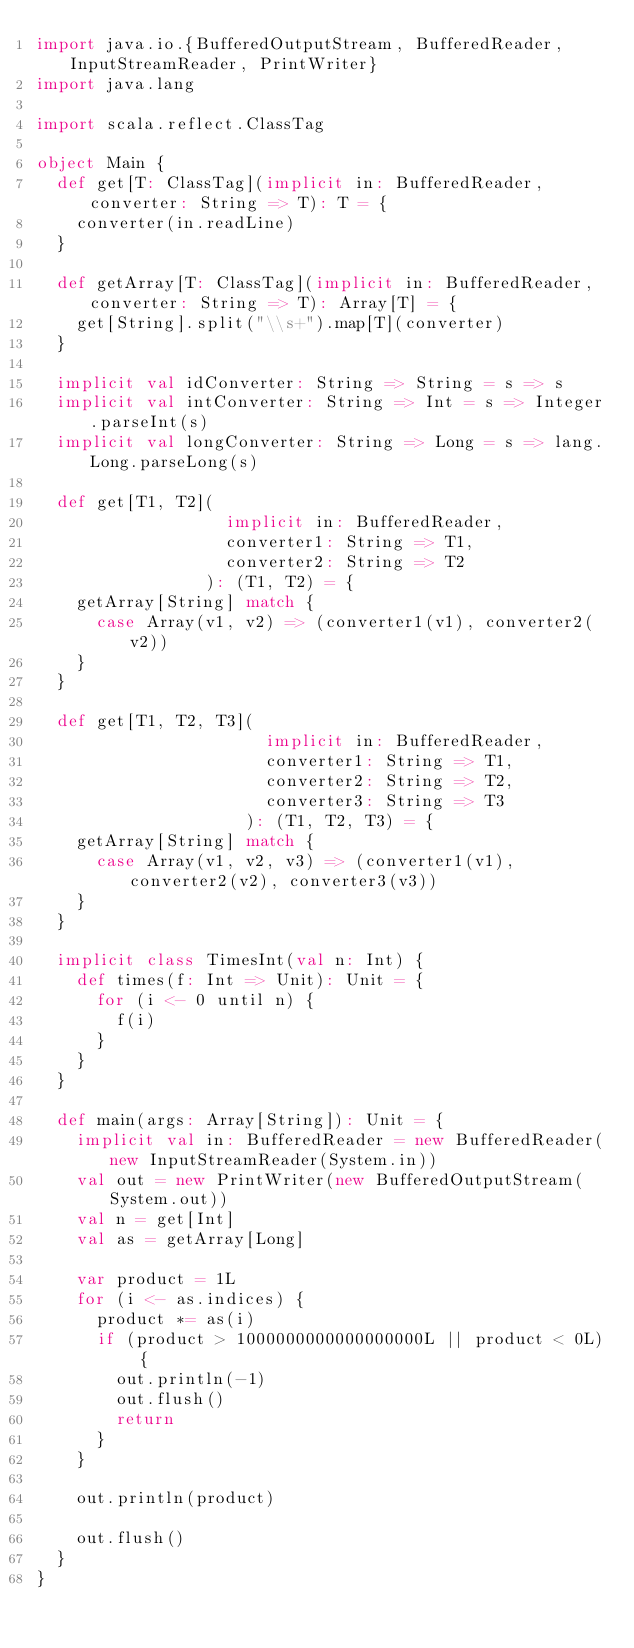<code> <loc_0><loc_0><loc_500><loc_500><_Scala_>import java.io.{BufferedOutputStream, BufferedReader, InputStreamReader, PrintWriter}
import java.lang

import scala.reflect.ClassTag

object Main {
  def get[T: ClassTag](implicit in: BufferedReader, converter: String => T): T = {
    converter(in.readLine)
  }

  def getArray[T: ClassTag](implicit in: BufferedReader, converter: String => T): Array[T] = {
    get[String].split("\\s+").map[T](converter)
  }

  implicit val idConverter: String => String = s => s
  implicit val intConverter: String => Int = s => Integer.parseInt(s)
  implicit val longConverter: String => Long = s => lang.Long.parseLong(s)

  def get[T1, T2](
                   implicit in: BufferedReader,
                   converter1: String => T1,
                   converter2: String => T2
                 ): (T1, T2) = {
    getArray[String] match {
      case Array(v1, v2) => (converter1(v1), converter2(v2))
    }
  }

  def get[T1, T2, T3](
                       implicit in: BufferedReader,
                       converter1: String => T1,
                       converter2: String => T2,
                       converter3: String => T3
                     ): (T1, T2, T3) = {
    getArray[String] match {
      case Array(v1, v2, v3) => (converter1(v1), converter2(v2), converter3(v3))
    }
  }

  implicit class TimesInt(val n: Int) {
    def times(f: Int => Unit): Unit = {
      for (i <- 0 until n) {
        f(i)
      }
    }
  }

  def main(args: Array[String]): Unit = {
    implicit val in: BufferedReader = new BufferedReader(new InputStreamReader(System.in))
    val out = new PrintWriter(new BufferedOutputStream(System.out))
    val n = get[Int]
    val as = getArray[Long]

    var product = 1L
    for (i <- as.indices) {
      product *= as(i)
      if (product > 1000000000000000000L || product < 0L) {
        out.println(-1)
        out.flush()
        return
      }
    }

    out.println(product)

    out.flush()
  }
}</code> 